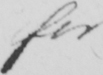What is written in this line of handwriting? for 